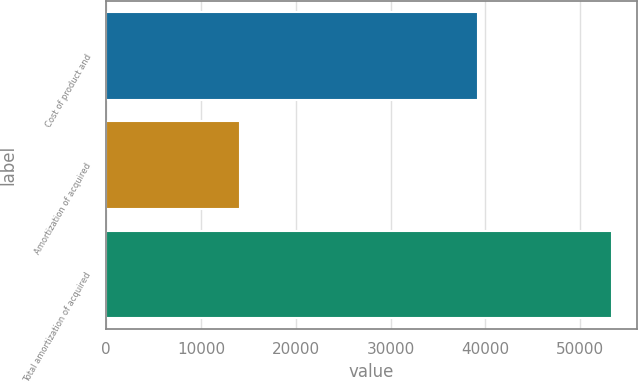<chart> <loc_0><loc_0><loc_500><loc_500><bar_chart><fcel>Cost of product and<fcel>Amortization of acquired<fcel>Total amortization of acquired<nl><fcel>39247<fcel>14086<fcel>53333<nl></chart> 